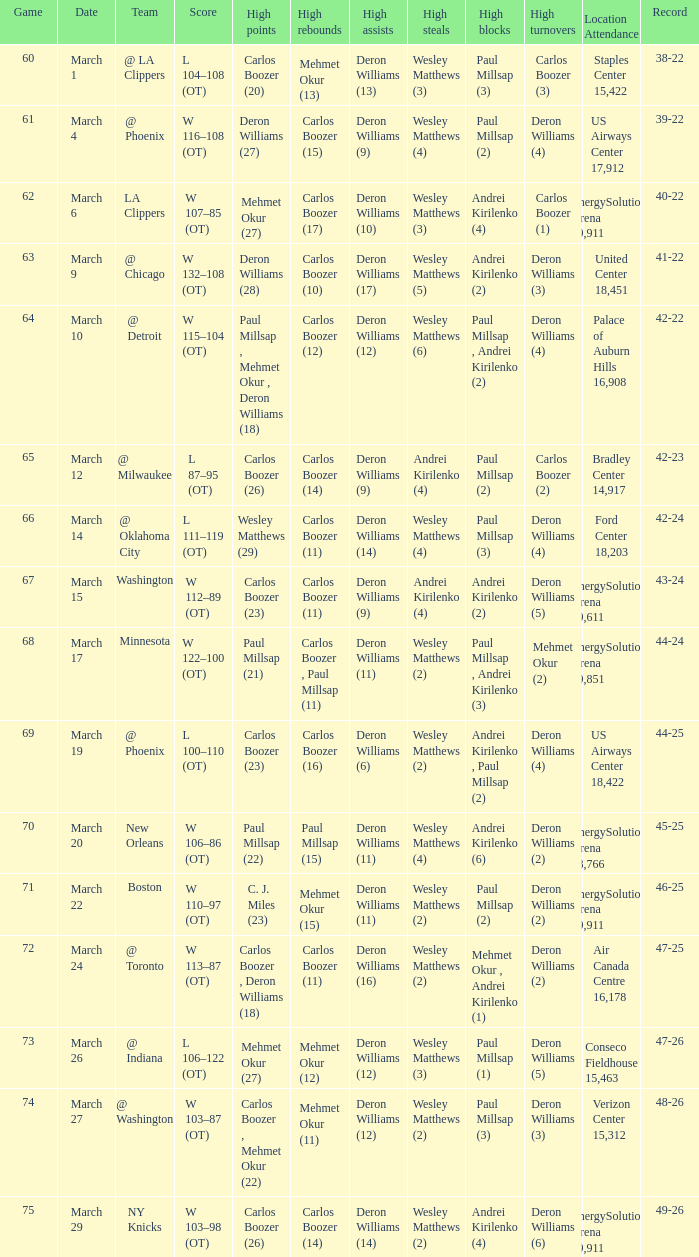How many different players did the most high assists on the March 4 game? 1.0. 